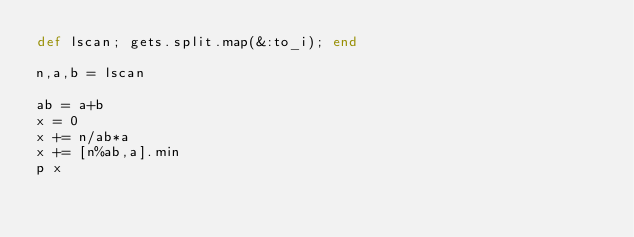<code> <loc_0><loc_0><loc_500><loc_500><_Ruby_>def lscan; gets.split.map(&:to_i); end

n,a,b = lscan

ab = a+b
x = 0
x += n/ab*a
x += [n%ab,a].min
p x </code> 